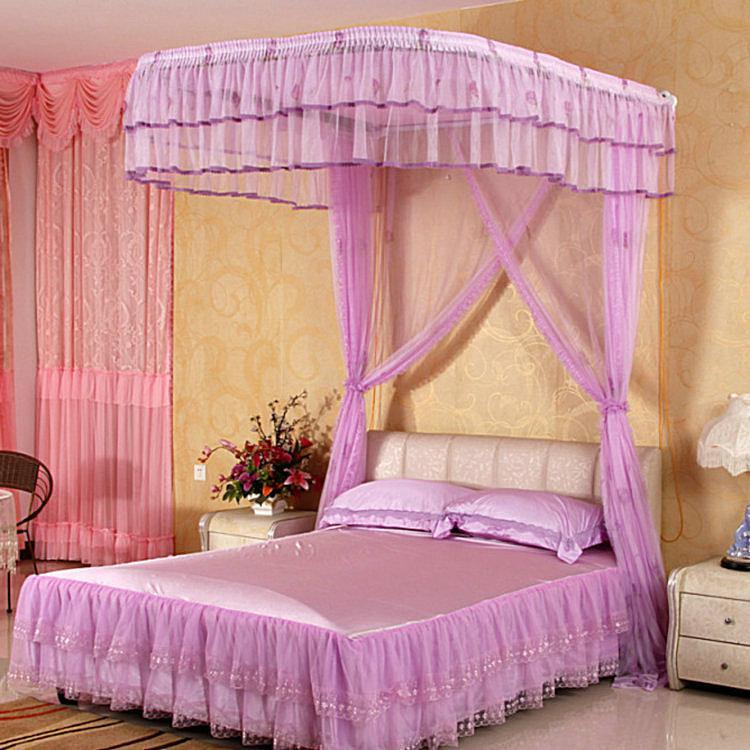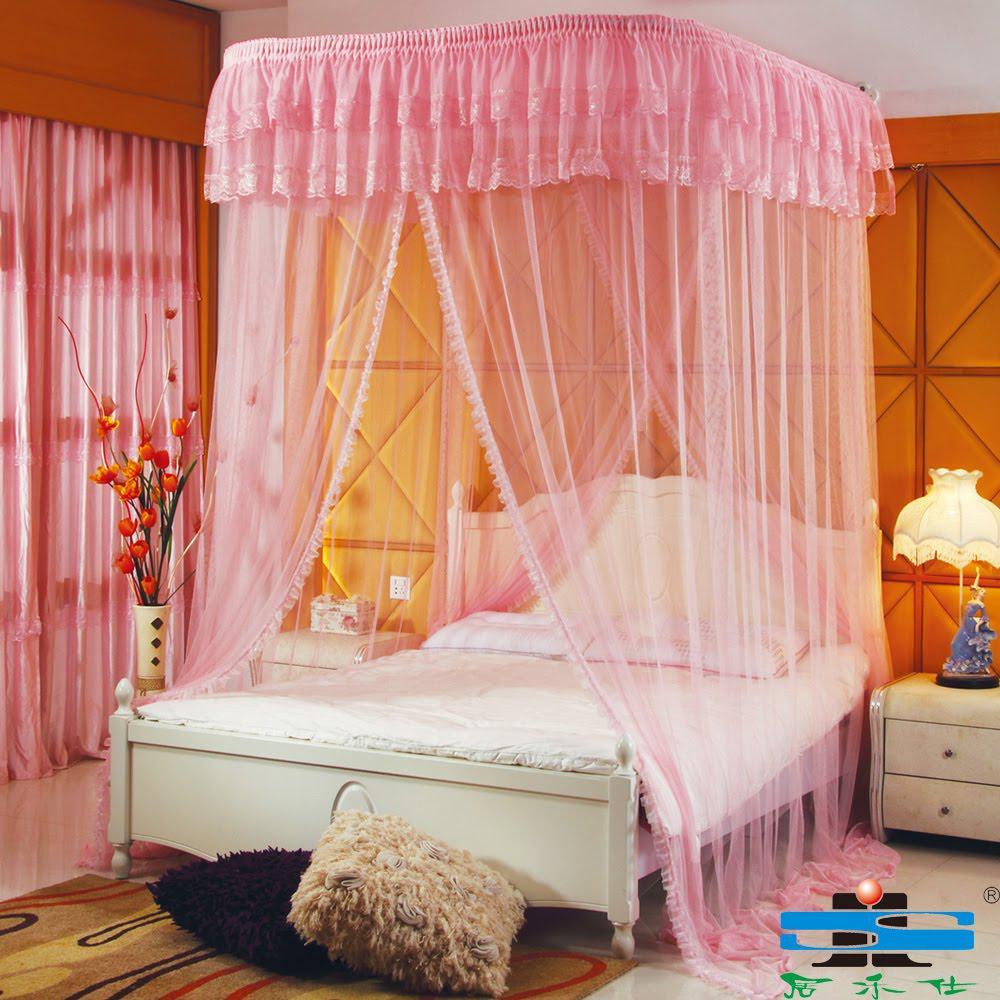The first image is the image on the left, the second image is the image on the right. Evaluate the accuracy of this statement regarding the images: "At least one bed has a pink canopy.". Is it true? Answer yes or no. Yes. The first image is the image on the left, the second image is the image on the right. Analyze the images presented: Is the assertion "There is a table lamp in the image on the left." valid? Answer yes or no. Yes. 